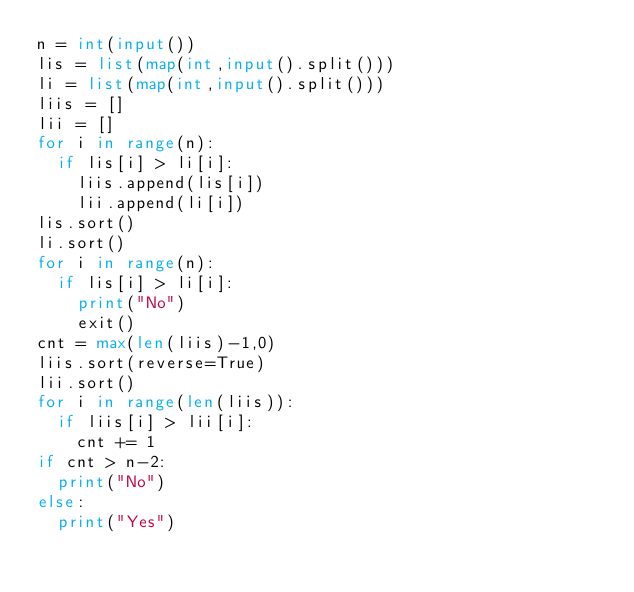Convert code to text. <code><loc_0><loc_0><loc_500><loc_500><_Python_>n = int(input())
lis = list(map(int,input().split()))
li = list(map(int,input().split()))
liis = []
lii = []
for i in range(n):
  if lis[i] > li[i]:
    liis.append(lis[i])
    lii.append(li[i])
lis.sort()
li.sort()
for i in range(n):
  if lis[i] > li[i]:
    print("No")
    exit()
cnt = max(len(liis)-1,0)
liis.sort(reverse=True)
lii.sort()
for i in range(len(liis)):
  if liis[i] > lii[i]:
    cnt += 1
if cnt > n-2:
  print("No")
else:
  print("Yes")</code> 